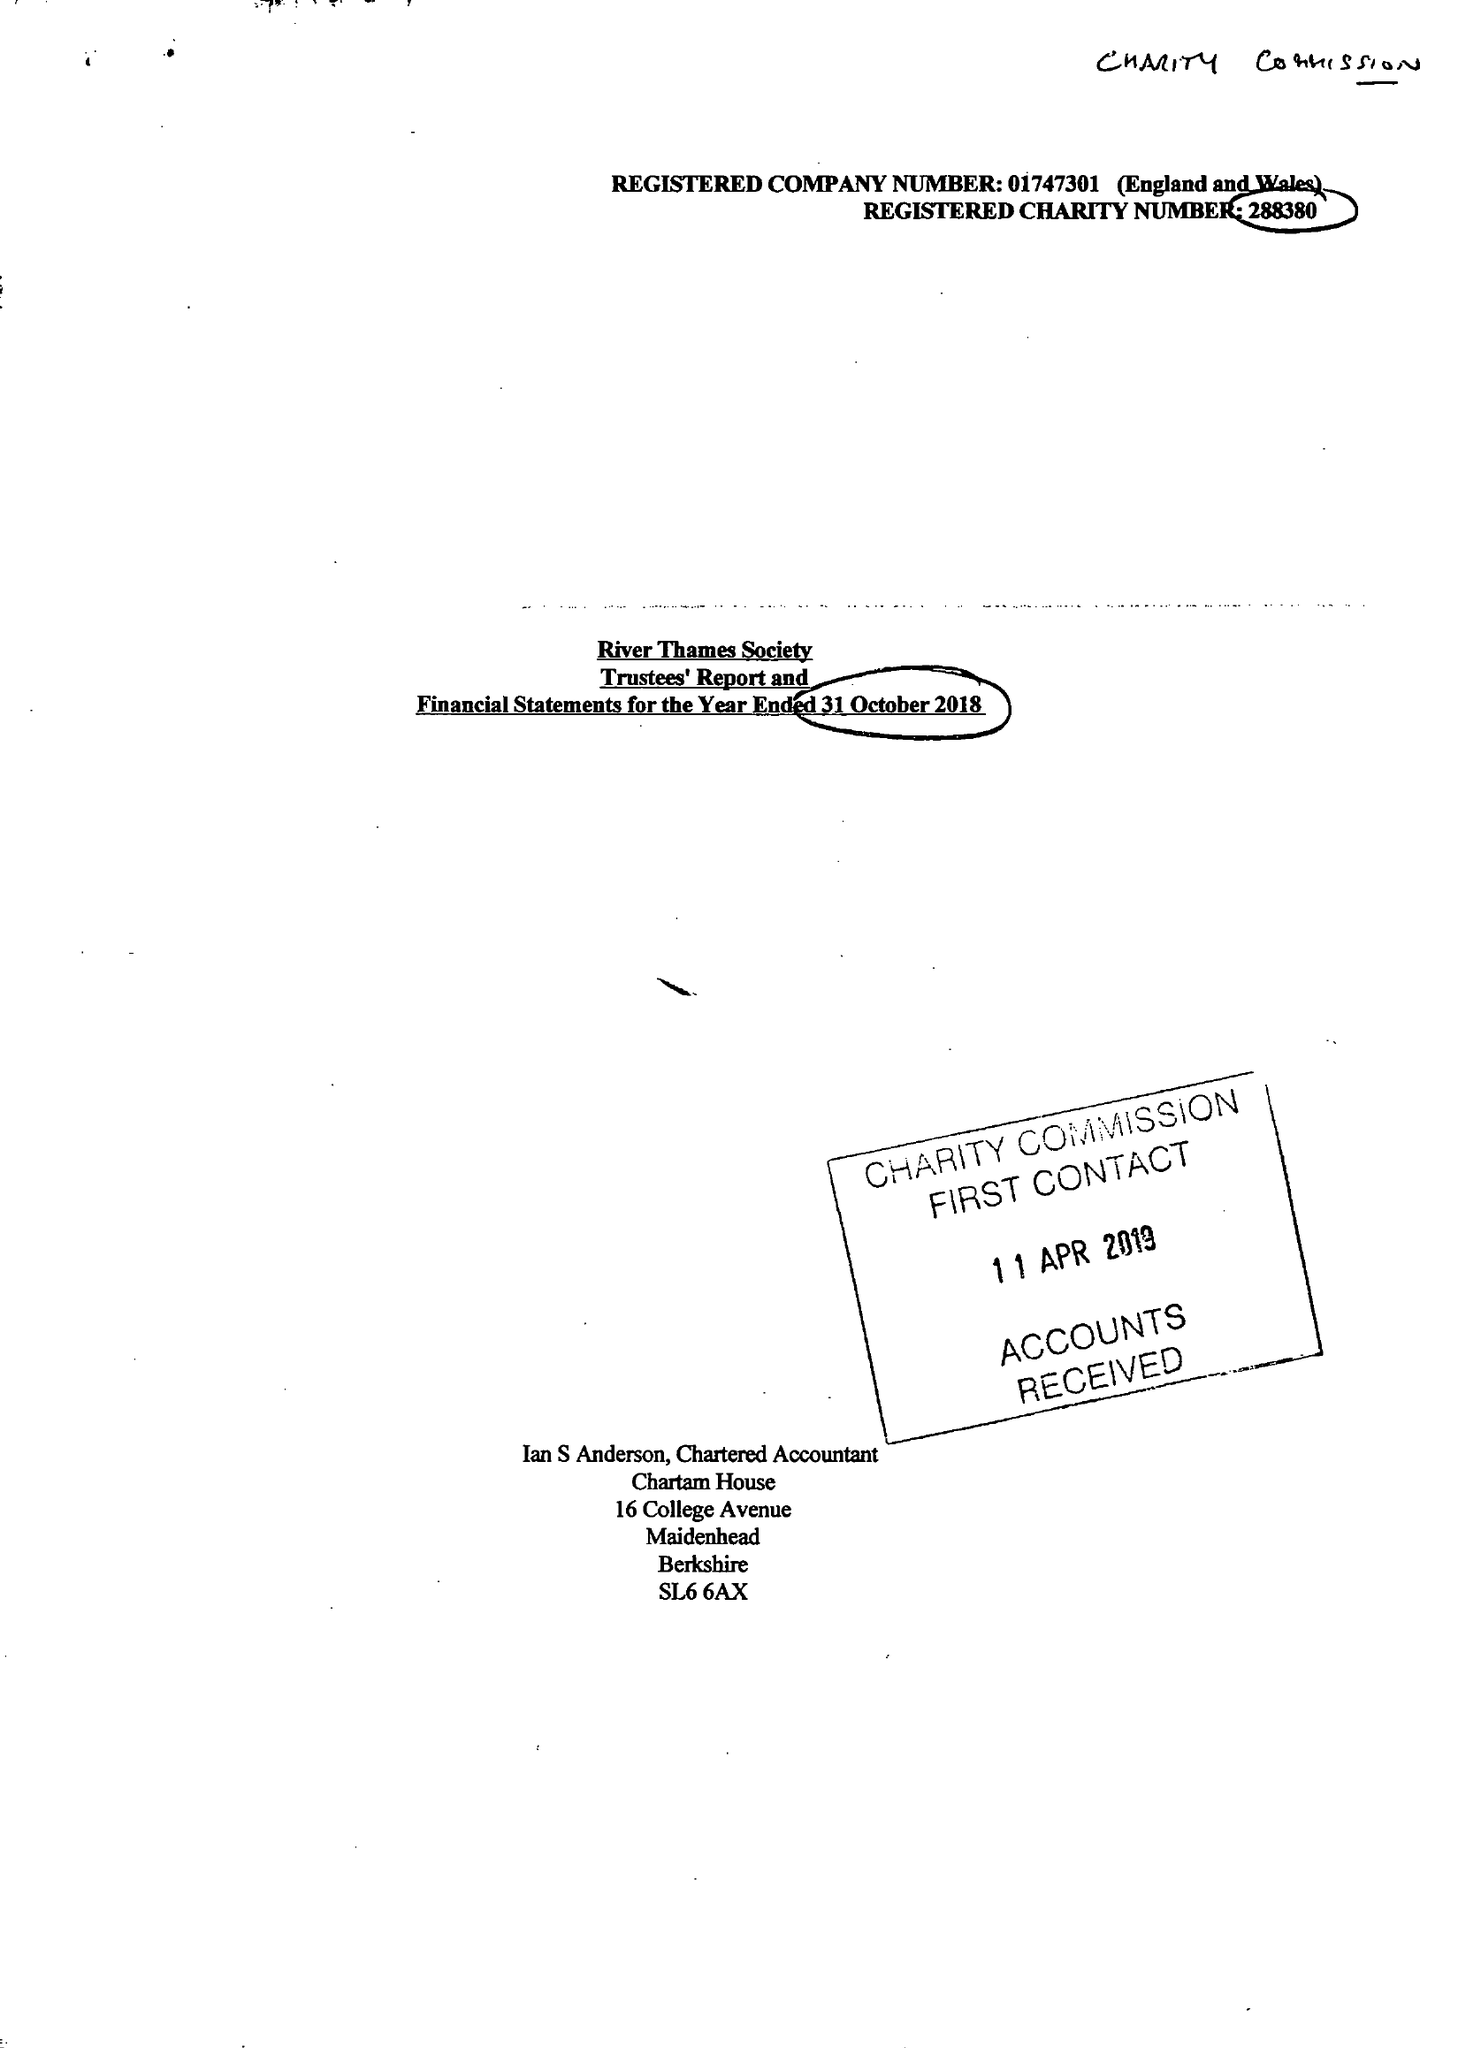What is the value for the charity_name?
Answer the question using a single word or phrase. River Thames Society 